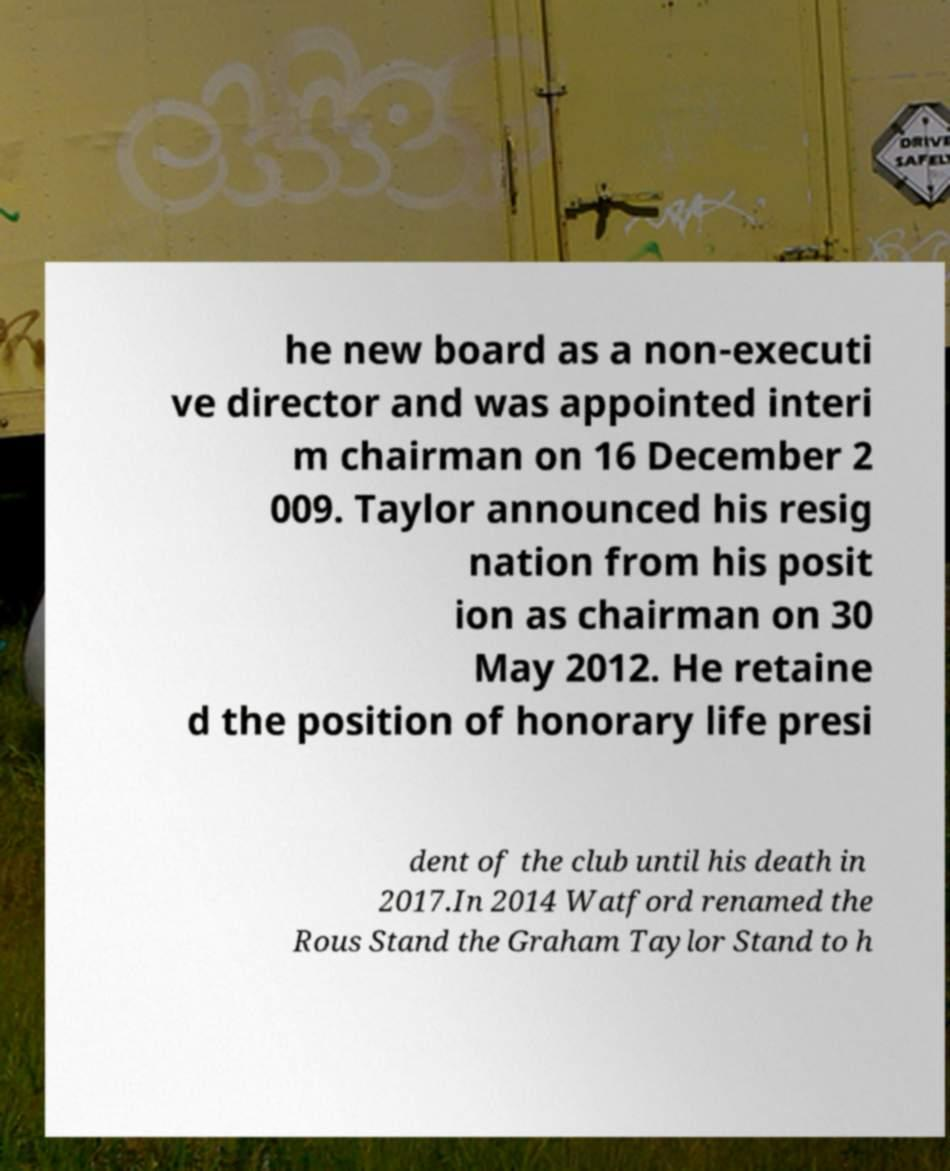Could you assist in decoding the text presented in this image and type it out clearly? he new board as a non-executi ve director and was appointed interi m chairman on 16 December 2 009. Taylor announced his resig nation from his posit ion as chairman on 30 May 2012. He retaine d the position of honorary life presi dent of the club until his death in 2017.In 2014 Watford renamed the Rous Stand the Graham Taylor Stand to h 